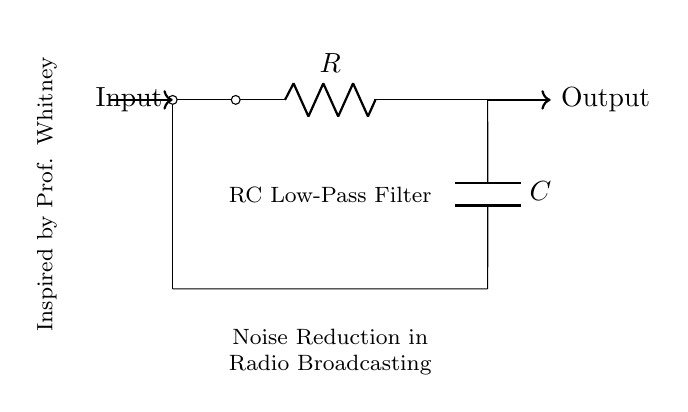What components are in the circuit? The circuit contains a resistor and a capacitor, as indicated by the labels R and C in the diagram.
Answer: Resistor, Capacitor What is the function of this circuit? This RC circuit serves as a low-pass filter, allowing signals below a certain frequency to pass while reducing higher frequency noise.
Answer: Noise Reduction What are the input and output locations in the circuit? The input is at the left side of the circuit, where the arrow points into the circuit, and the output is at the right side, where the arrow points out.
Answer: Left input, Right output What type of filter is represented in this circuit? The circuit is identified as a low-pass filter, which means it passes low-frequency signals while attenuating high-frequency signals.
Answer: Low-Pass Filter How does the resistor value affect the filter's cutoff frequency? The cutoff frequency depends on both resistor and capacitor values through the formula, where a higher resistor value increases the cutoff frequency. Thus, altering R affects the filter's response.
Answer: Increases cutoff frequency What inspired the design of this circuit? The circuit is inspired by Professor Whitney, as noted in the diagram, suggesting an influential figure in the design or theory applied here.
Answer: Professor Whitney What is the role of the capacitor in this RC filter? The capacitor in this circuit stores energy temporarily and, with the resistor, helps establish the time constant that defines the filter's cutoff frequency.
Answer: Energy Storage 